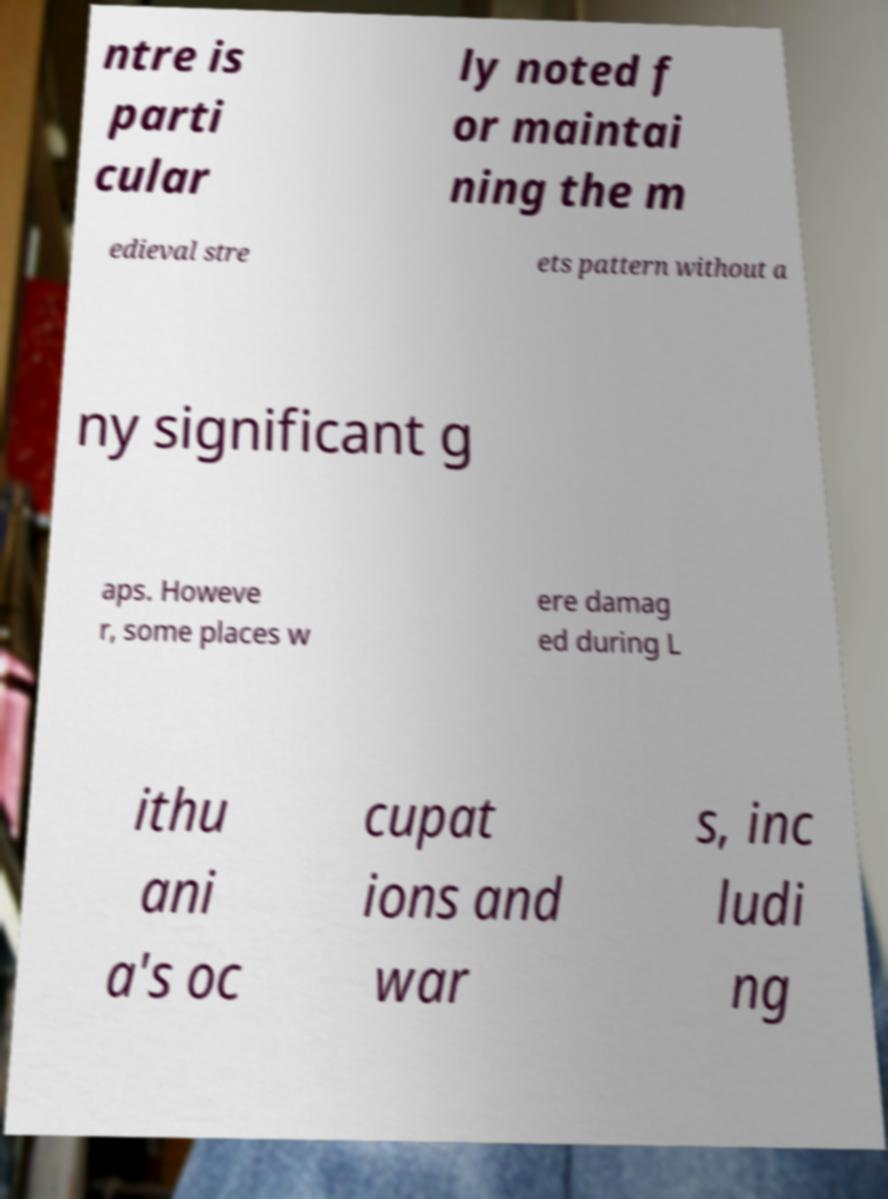Can you read and provide the text displayed in the image?This photo seems to have some interesting text. Can you extract and type it out for me? ntre is parti cular ly noted f or maintai ning the m edieval stre ets pattern without a ny significant g aps. Howeve r, some places w ere damag ed during L ithu ani a's oc cupat ions and war s, inc ludi ng 